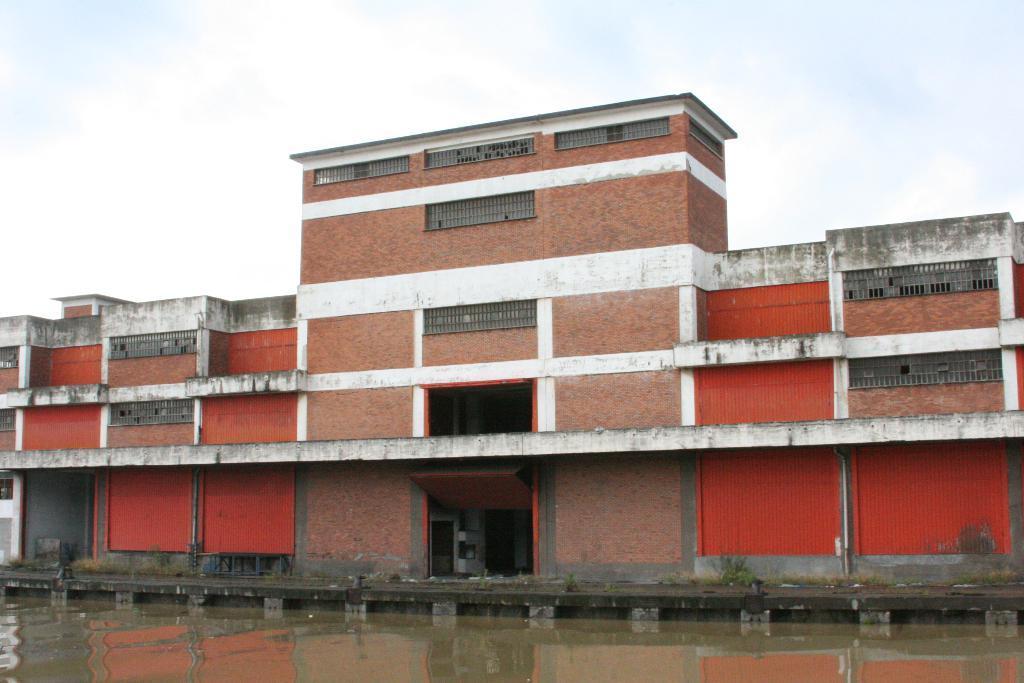In one or two sentences, can you explain what this image depicts? In this picture we can see water, path, plants, building and some objects and in the background we can see the sky. 